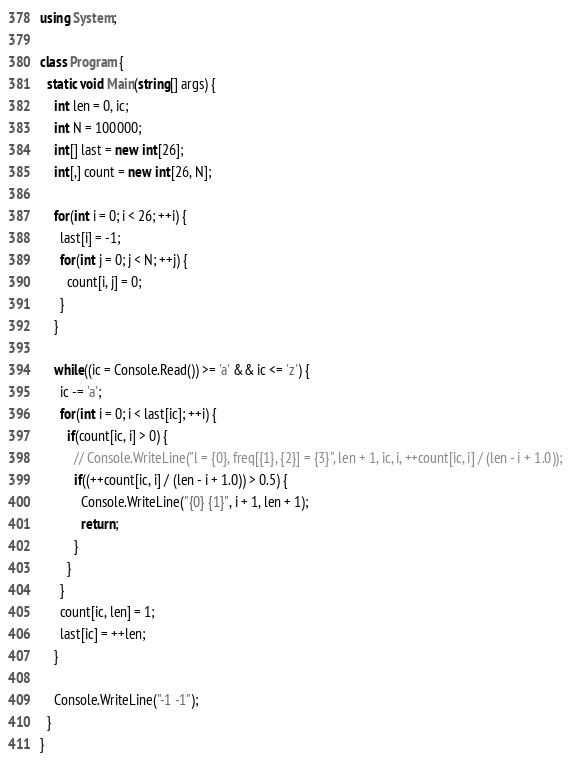<code> <loc_0><loc_0><loc_500><loc_500><_C#_>using System;

class Program {
  static void Main(string[] args) {
    int len = 0, ic;
    int N = 100000;
    int[] last = new int[26];
    int[,] count = new int[26, N];

    for(int i = 0; i < 26; ++i) {
      last[i] = -1;
      for(int j = 0; j < N; ++j) {
        count[i, j] = 0;
      }
    }

    while((ic = Console.Read()) >= 'a' && ic <= 'z') {
      ic -= 'a';
      for(int i = 0; i < last[ic]; ++i) {
        if(count[ic, i] > 0) {
          // Console.WriteLine("l = {0}, freq[{1}, {2}] = {3}", len + 1, ic, i, ++count[ic, i] / (len - i + 1.0));
          if((++count[ic, i] / (len - i + 1.0)) > 0.5) {
            Console.WriteLine("{0} {1}", i + 1, len + 1);
            return;
          }
        }
      }
      count[ic, len] = 1;
      last[ic] = ++len;
    }

    Console.WriteLine("-1 -1");
  }
}
</code> 